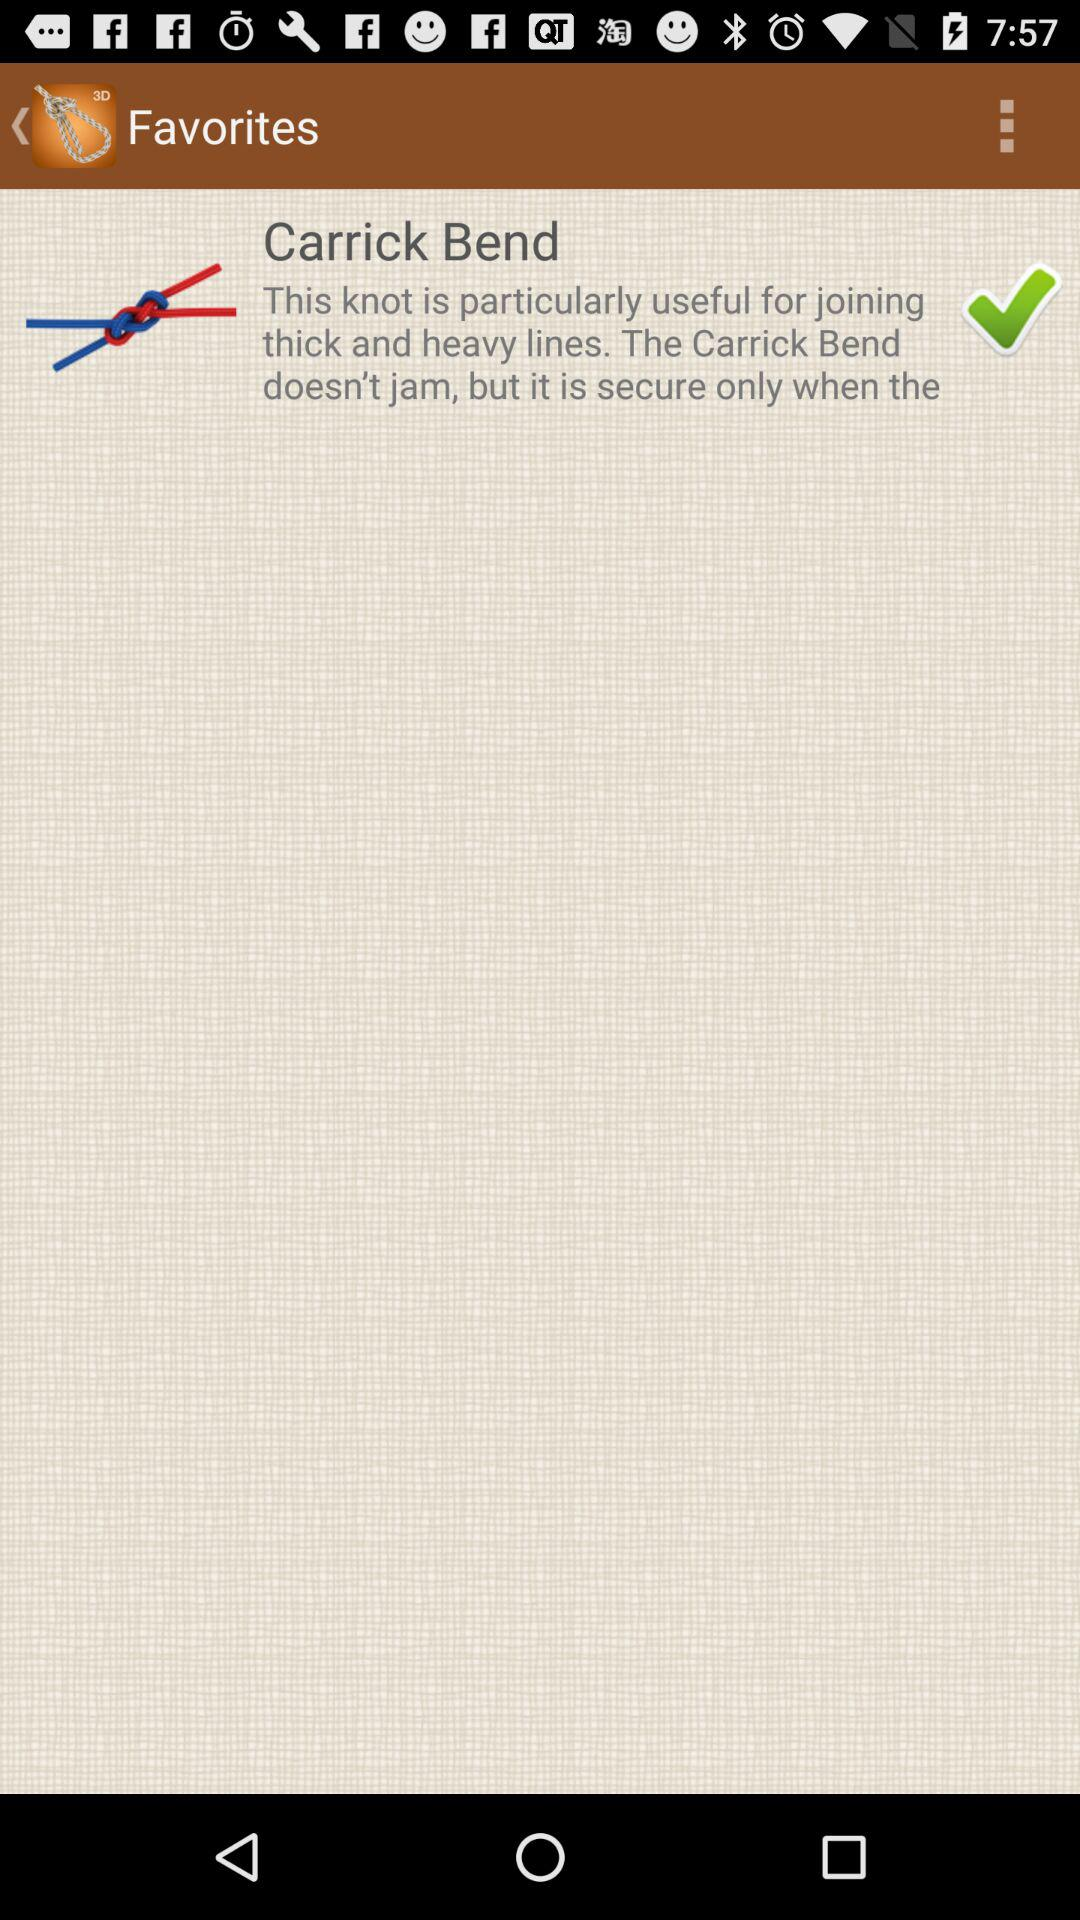What type of knot is useful for joining thick and heavy lines? The type of knot is "Carrick Bend". 